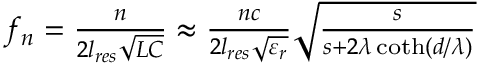<formula> <loc_0><loc_0><loc_500><loc_500>\begin{array} { r } { f _ { n } = \frac { n } { 2 l _ { r e s } \sqrt { L C } } \approx \frac { n c } { 2 l _ { r e s } \sqrt { \varepsilon _ { r } } } \sqrt { \frac { s } { s + 2 \lambda \coth ( d / \lambda ) } } } \end{array}</formula> 